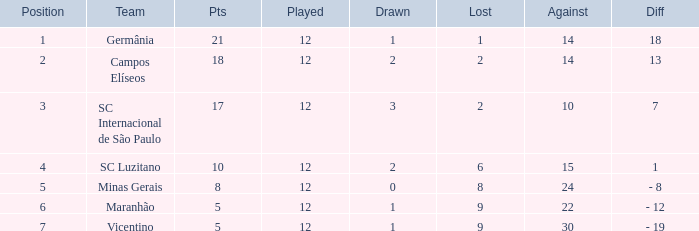What difference has a points greater than 10, and a drawn less than 2? 18.0. 